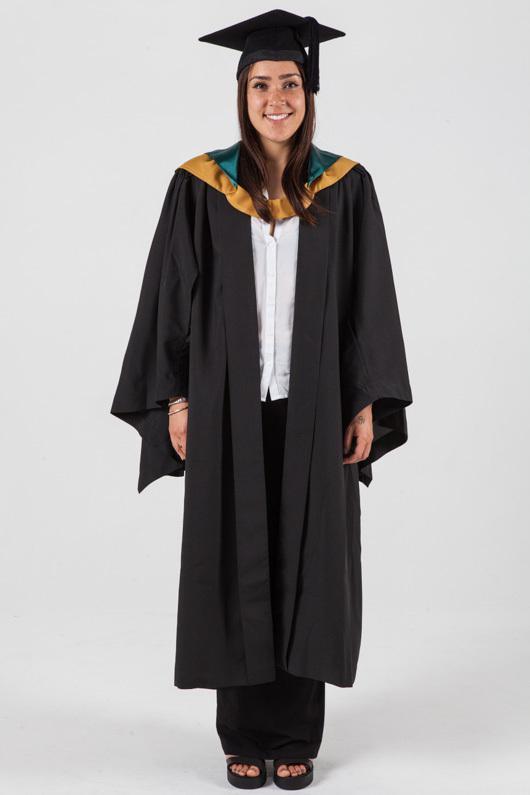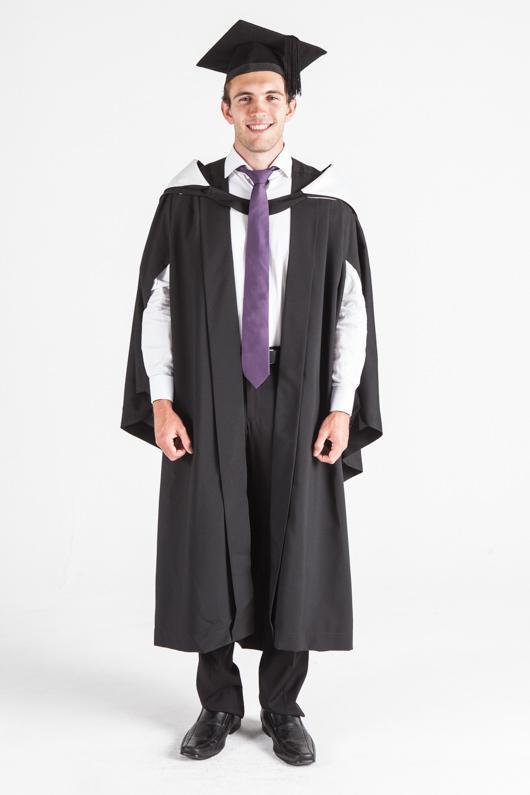The first image is the image on the left, the second image is the image on the right. Examine the images to the left and right. Is the description "Exactly one camera-facing female and one camera-facing male are shown modeling graduation attire." accurate? Answer yes or no. Yes. The first image is the image on the left, the second image is the image on the right. Assess this claim about the two images: "The graduation attire in the image on the left is being modeled by a female.". Correct or not? Answer yes or no. Yes. 